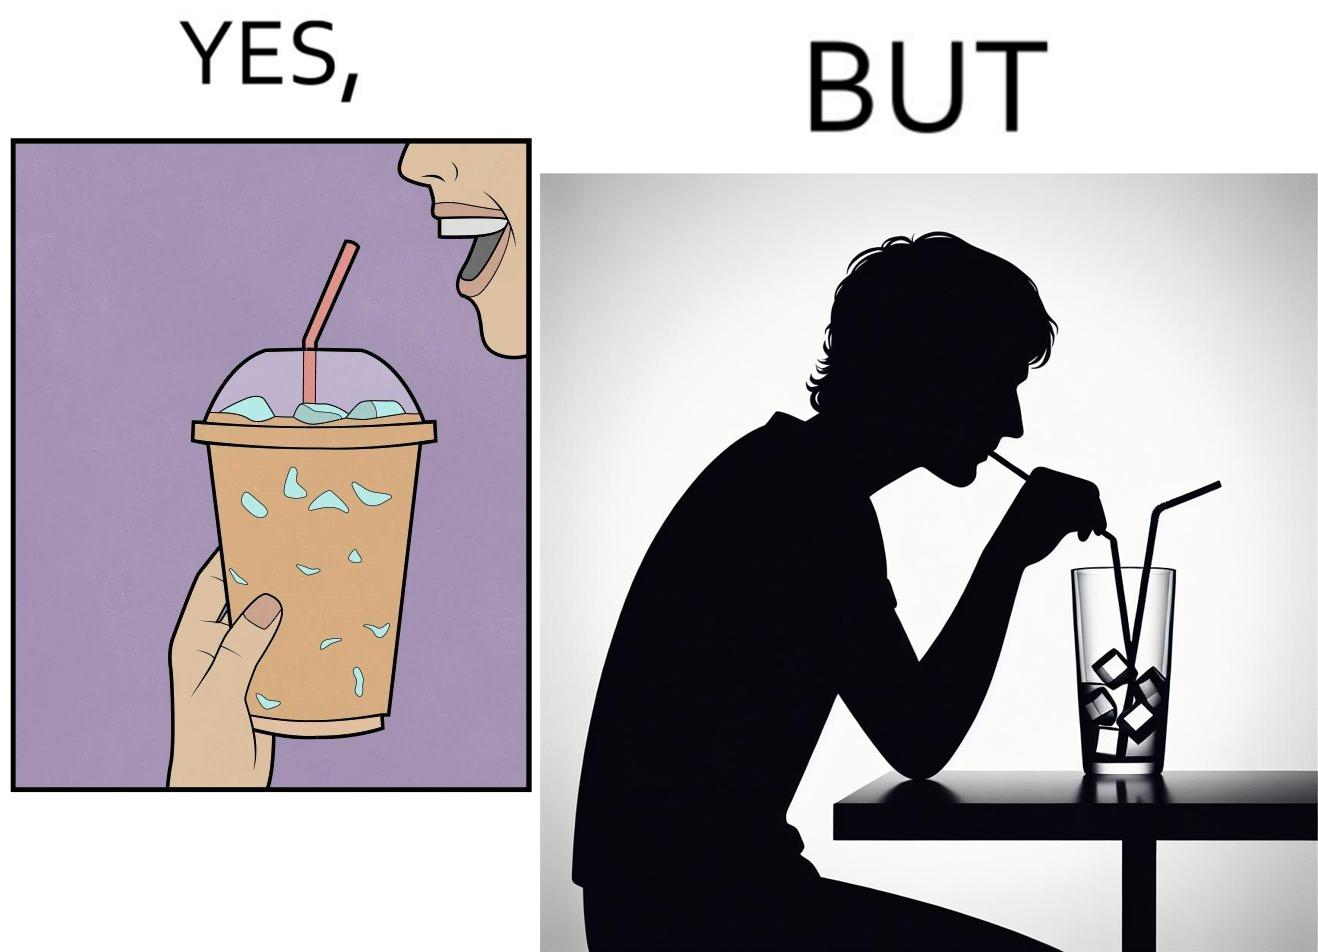What do you see in each half of this image? In the left part of the image: A person holding a drink with ice cubes, with a straw in the drink. In the right part of the image: A person drinking out of a straw from a drink. The drink is almost finished, and only I've cubes are left. 